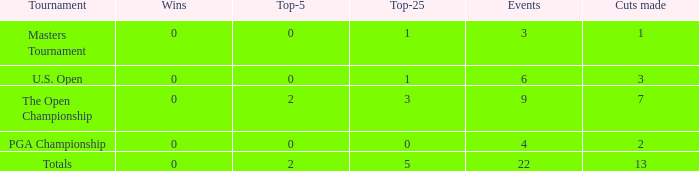In events with more than 13 cuts made, what is the smallest number of top-25 placements? None. 